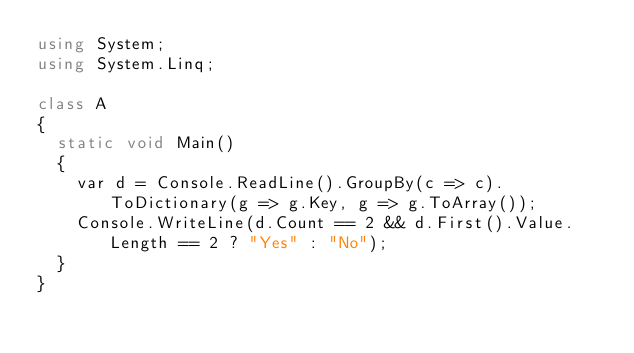<code> <loc_0><loc_0><loc_500><loc_500><_C#_>using System;
using System.Linq;

class A
{
	static void Main()
	{
		var d = Console.ReadLine().GroupBy(c => c).ToDictionary(g => g.Key, g => g.ToArray());
		Console.WriteLine(d.Count == 2 && d.First().Value.Length == 2 ? "Yes" : "No");
	}
}
</code> 